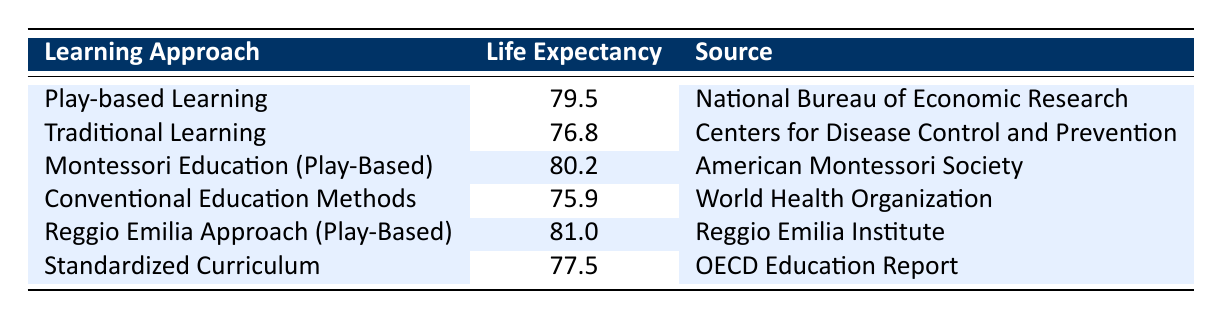What is the average life expectancy for students engaging in play-based learning? The table shows that for "Play-based Learning," the average life expectancy is 79.5.
Answer: 79.5 What is the average life expectancy for students using traditional learning methods? The average life expectancy listed for "Traditional Learning" is 76.8.
Answer: 76.8 Which learning approach has the highest average life expectancy? By comparing all values in the table, "Reggio Emilia Approach (Play-Based)" has the highest at 81.0.
Answer: 81.0 How much longer do students engaging in Montessori Education (Play-Based) live compared to those in Conventional Education Methods? The life expectancy for Montessori Education (Play-Based) is 80.2, and for Conventional Education Methods, it is 75.9. The difference is 80.2 - 75.9 = 4.3.
Answer: 4.3 Is the average life expectancy higher in play-based learning approaches compared to traditional learning approaches? Yes, "Play-based Learning" (79.5) is higher than "Traditional Learning" (76.8).
Answer: Yes What is the average life expectancy of all the learning approaches listed in the table? The averages are 79.5 (Play-based Learning), 76.8 (Traditional Learning), 80.2 (Montessori), 75.9 (Conventional), 81.0 (Reggio Emilia), and 77.5 (Standardized) which sums to 471.4. Dividing by the six approaches gives 471.4/6 = 78.57.
Answer: 78.57 By how much does the life expectancy of students in the Standardized Curriculum exceed that of those in Conventional Education Methods? The Standardized Curriculum has an average life expectancy of 77.5, while Conventional Education Methods have 75.9. The difference is 77.5 - 75.9 = 1.6.
Answer: 1.6 Is the source for the life expectancy of Montessori Education (Play-Based) from an educational organization? Yes, the source for Montessori Education (Play-Based) is the "American Montessori Society," which is an educational organization.
Answer: Yes Does the table indicate that students in play-based learning environments tend to have a life expectancy higher than students in standardized curricula? Yes, the average life expectancy for "Play-based Learning" is 79.5, while "Standardized Curriculum" is 77.5, showing a higher figure for play-based learning.
Answer: Yes 